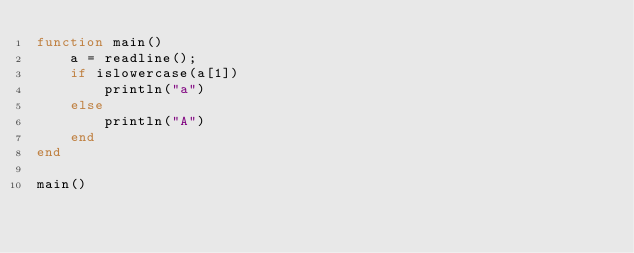Convert code to text. <code><loc_0><loc_0><loc_500><loc_500><_Julia_>function main()
    a = readline();
    if islowercase(a[1])
        println("a")
    else
        println("A")
    end
end

main()</code> 